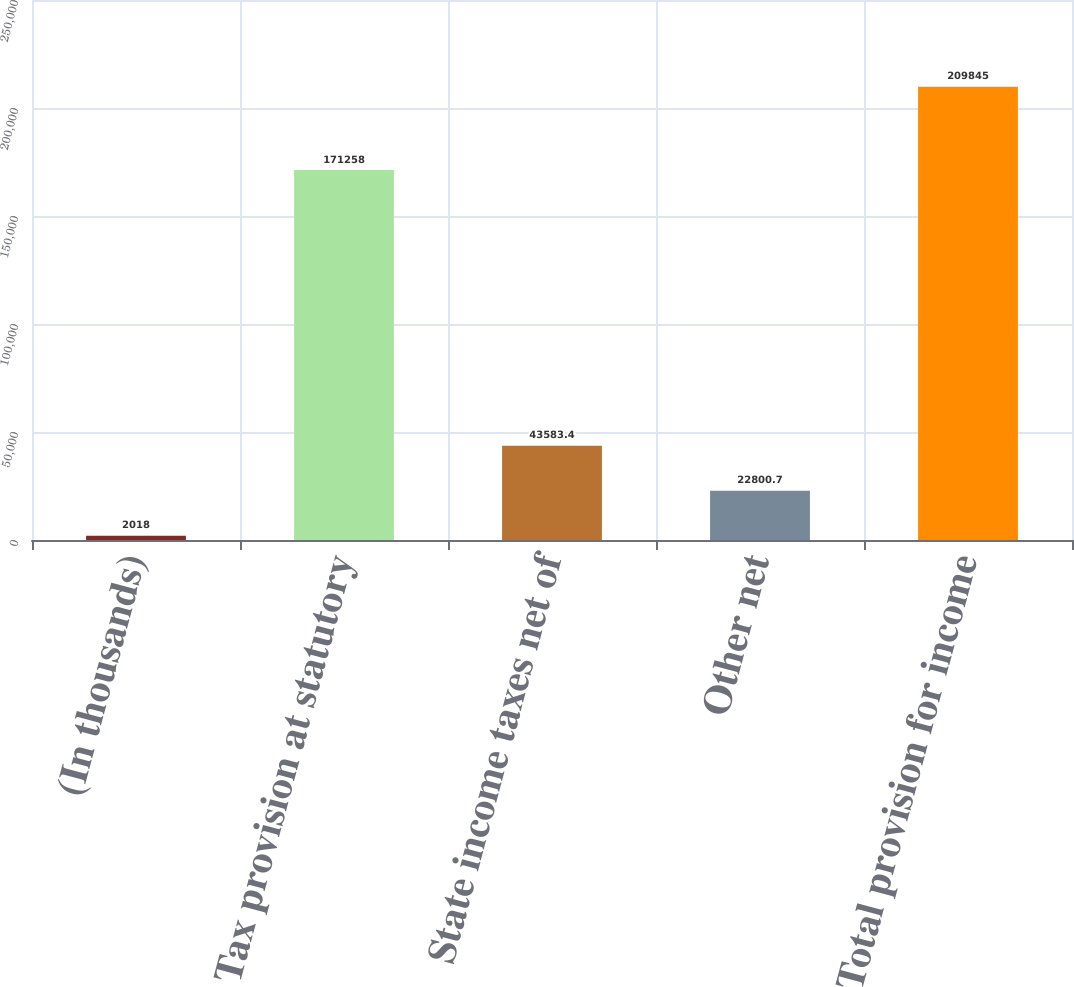Convert chart. <chart><loc_0><loc_0><loc_500><loc_500><bar_chart><fcel>(In thousands)<fcel>Tax provision at statutory<fcel>State income taxes net of<fcel>Other net<fcel>Total provision for income<nl><fcel>2018<fcel>171258<fcel>43583.4<fcel>22800.7<fcel>209845<nl></chart> 